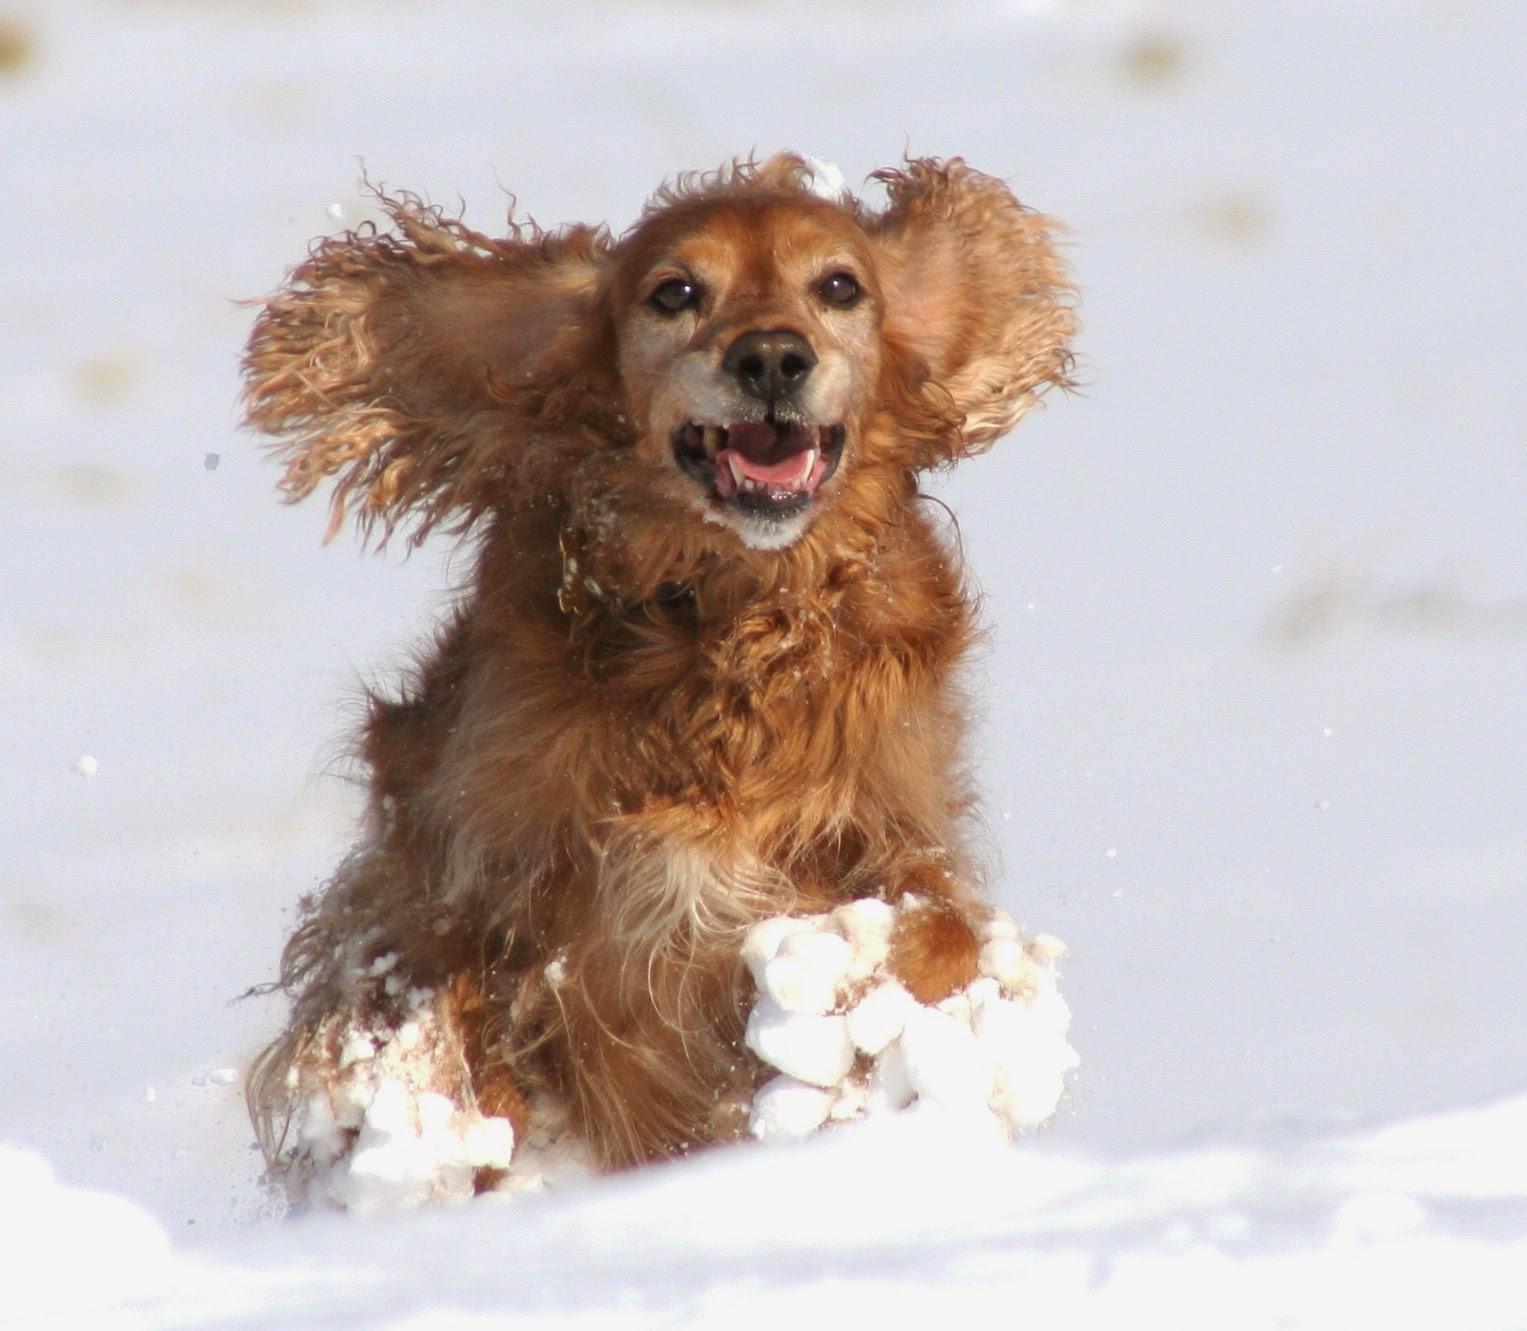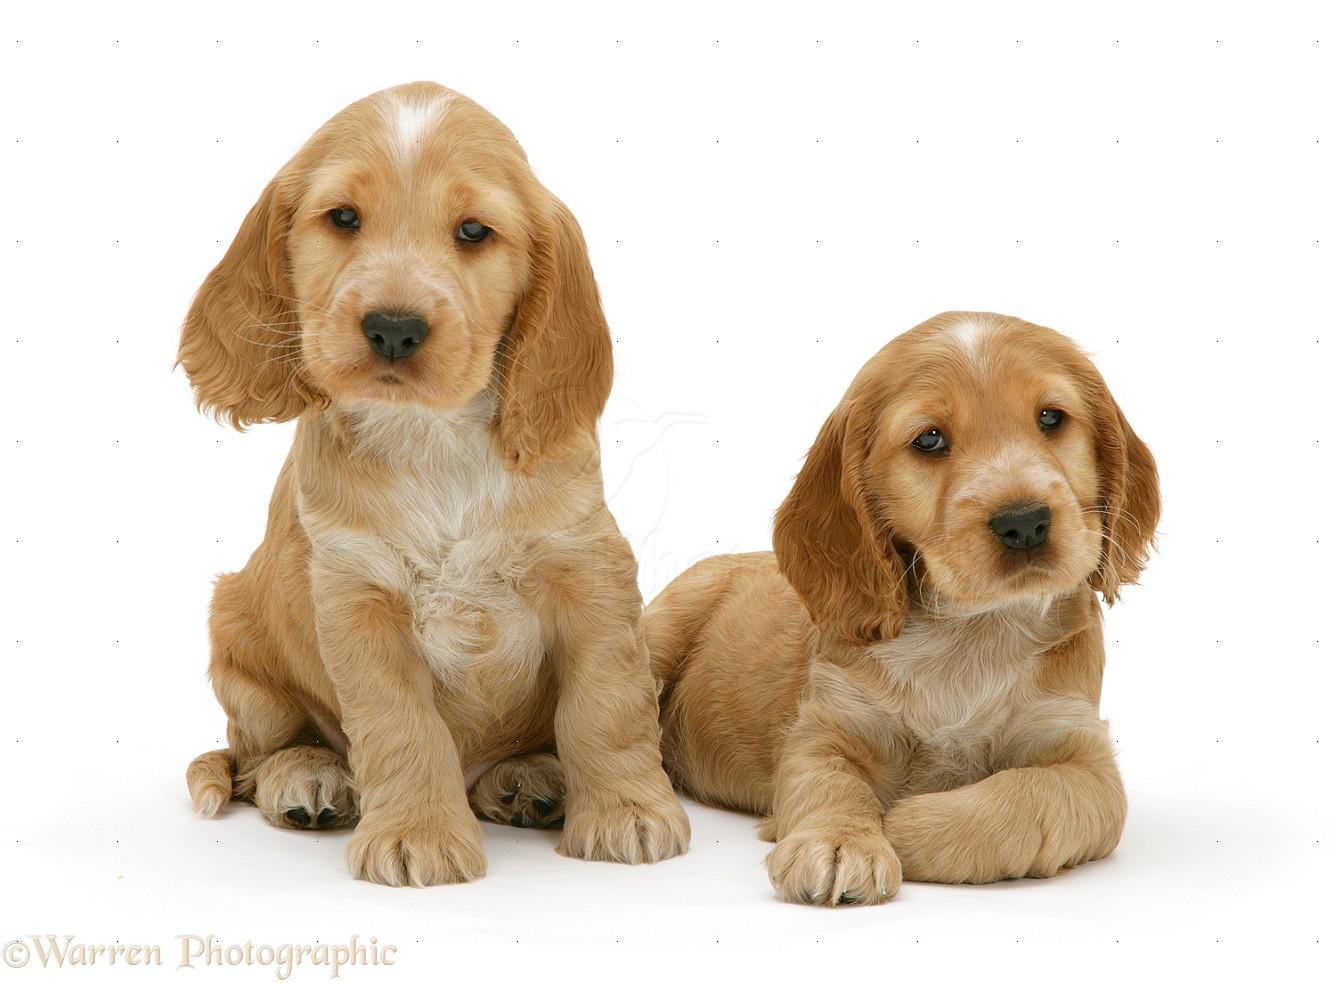The first image is the image on the left, the second image is the image on the right. Assess this claim about the two images: "There are a total of 4 dogs present.". Correct or not? Answer yes or no. No. The first image is the image on the left, the second image is the image on the right. Evaluate the accuracy of this statement regarding the images: "there are 3 dogs in the image pair". Is it true? Answer yes or no. Yes. 